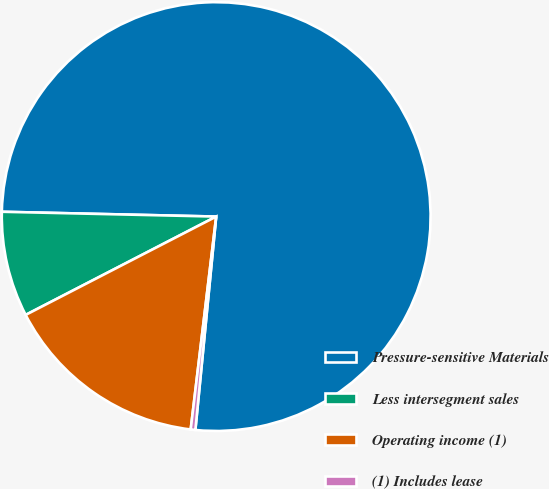<chart> <loc_0><loc_0><loc_500><loc_500><pie_chart><fcel>Pressure-sensitive Materials<fcel>Less intersegment sales<fcel>Operating income (1)<fcel>(1) Includes lease<nl><fcel>76.19%<fcel>7.94%<fcel>15.52%<fcel>0.35%<nl></chart> 